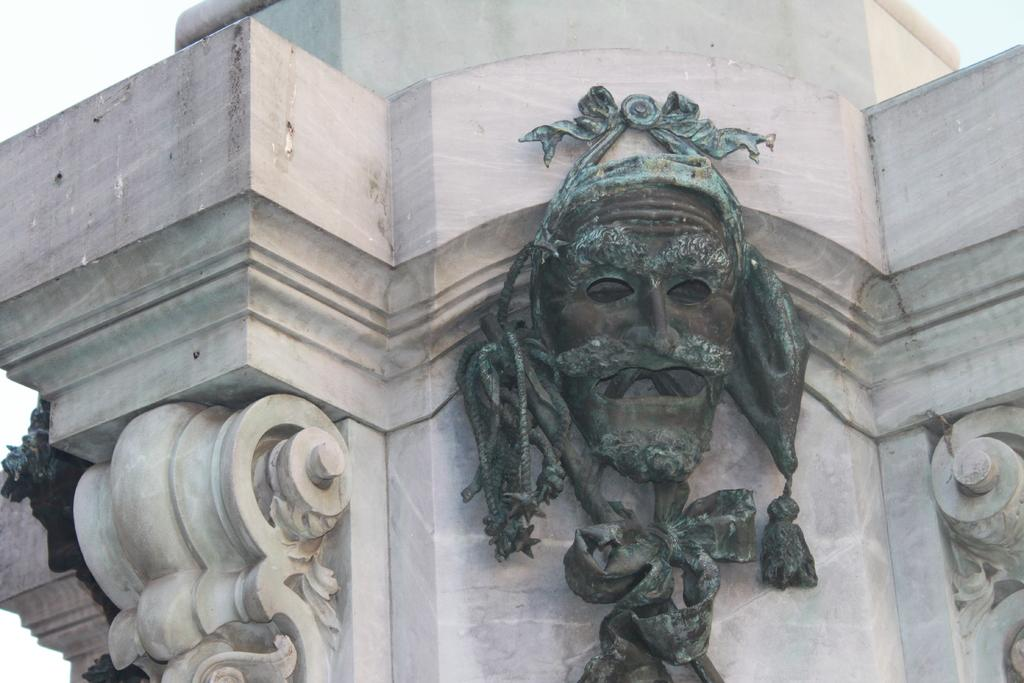What object is present in the image? There is a mask in the image. Where is the mask located? The mask is hanged on a wall. What type of cloth is used to make the jam in the image? There is no cloth or jam present in the image; it only features a mask hung on a wall. 